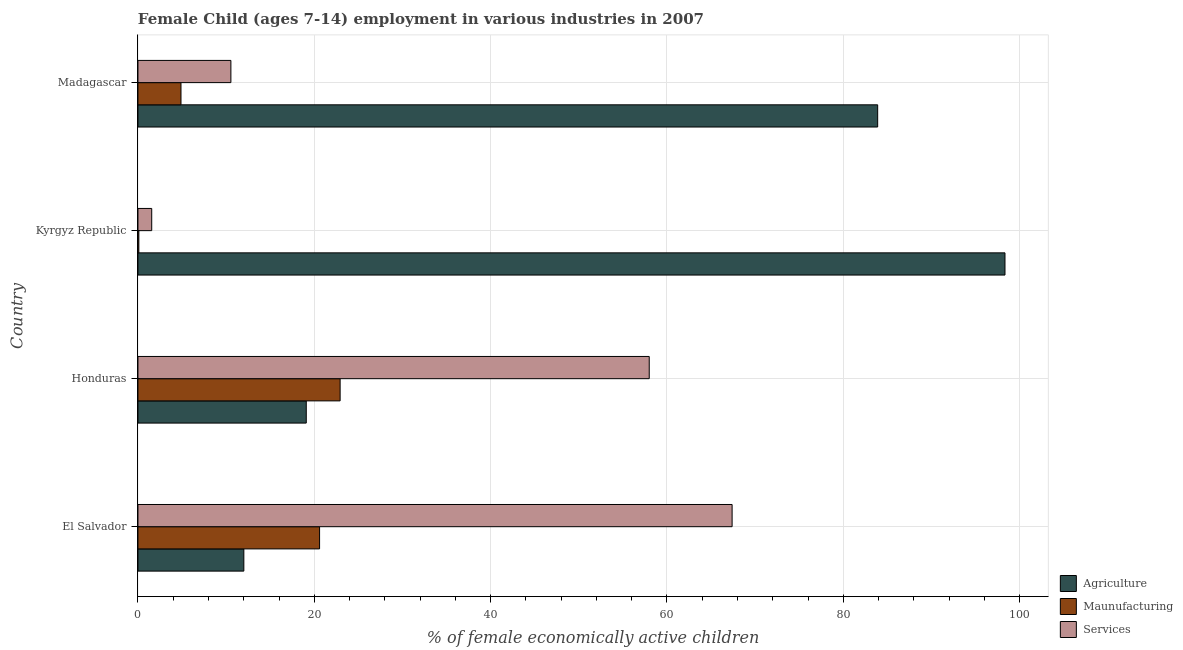How many different coloured bars are there?
Keep it short and to the point. 3. How many groups of bars are there?
Keep it short and to the point. 4. Are the number of bars per tick equal to the number of legend labels?
Give a very brief answer. Yes. Are the number of bars on each tick of the Y-axis equal?
Your answer should be very brief. Yes. How many bars are there on the 1st tick from the top?
Your answer should be compact. 3. How many bars are there on the 3rd tick from the bottom?
Your answer should be very brief. 3. What is the label of the 2nd group of bars from the top?
Keep it short and to the point. Kyrgyz Republic. What is the percentage of economically active children in services in Honduras?
Keep it short and to the point. 57.99. Across all countries, what is the maximum percentage of economically active children in services?
Provide a succinct answer. 67.39. Across all countries, what is the minimum percentage of economically active children in services?
Make the answer very short. 1.56. In which country was the percentage of economically active children in manufacturing maximum?
Ensure brevity in your answer.  Honduras. In which country was the percentage of economically active children in services minimum?
Your answer should be compact. Kyrgyz Republic. What is the total percentage of economically active children in agriculture in the graph?
Your answer should be very brief. 213.34. What is the difference between the percentage of economically active children in services in Honduras and that in Madagascar?
Offer a very short reply. 47.45. What is the difference between the percentage of economically active children in services in Madagascar and the percentage of economically active children in manufacturing in El Salvador?
Your answer should be very brief. -10.06. What is the average percentage of economically active children in manufacturing per country?
Provide a succinct answer. 12.13. What is the difference between the percentage of economically active children in services and percentage of economically active children in manufacturing in El Salvador?
Your answer should be very brief. 46.79. In how many countries, is the percentage of economically active children in manufacturing greater than 68 %?
Provide a succinct answer. 0. What is the difference between the highest and the second highest percentage of economically active children in agriculture?
Your answer should be very brief. 14.44. What is the difference between the highest and the lowest percentage of economically active children in services?
Ensure brevity in your answer.  65.83. In how many countries, is the percentage of economically active children in agriculture greater than the average percentage of economically active children in agriculture taken over all countries?
Offer a very short reply. 2. Is the sum of the percentage of economically active children in agriculture in Honduras and Kyrgyz Republic greater than the maximum percentage of economically active children in services across all countries?
Your answer should be very brief. Yes. What does the 1st bar from the top in Kyrgyz Republic represents?
Make the answer very short. Services. What does the 1st bar from the bottom in El Salvador represents?
Provide a short and direct response. Agriculture. Are all the bars in the graph horizontal?
Keep it short and to the point. Yes. What is the difference between two consecutive major ticks on the X-axis?
Ensure brevity in your answer.  20. Are the values on the major ticks of X-axis written in scientific E-notation?
Ensure brevity in your answer.  No. Does the graph contain any zero values?
Your answer should be compact. No. Where does the legend appear in the graph?
Your response must be concise. Bottom right. How are the legend labels stacked?
Offer a very short reply. Vertical. What is the title of the graph?
Offer a terse response. Female Child (ages 7-14) employment in various industries in 2007. What is the label or title of the X-axis?
Offer a very short reply. % of female economically active children. What is the label or title of the Y-axis?
Your response must be concise. Country. What is the % of female economically active children of Agriculture in El Salvador?
Your answer should be compact. 12.01. What is the % of female economically active children in Maunufacturing in El Salvador?
Make the answer very short. 20.6. What is the % of female economically active children of Services in El Salvador?
Offer a very short reply. 67.39. What is the % of female economically active children of Agriculture in Honduras?
Provide a succinct answer. 19.09. What is the % of female economically active children in Maunufacturing in Honduras?
Your answer should be very brief. 22.93. What is the % of female economically active children of Services in Honduras?
Keep it short and to the point. 57.99. What is the % of female economically active children of Agriculture in Kyrgyz Republic?
Make the answer very short. 98.34. What is the % of female economically active children of Services in Kyrgyz Republic?
Offer a terse response. 1.56. What is the % of female economically active children of Agriculture in Madagascar?
Your answer should be compact. 83.9. What is the % of female economically active children in Maunufacturing in Madagascar?
Give a very brief answer. 4.88. What is the % of female economically active children of Services in Madagascar?
Keep it short and to the point. 10.54. Across all countries, what is the maximum % of female economically active children in Agriculture?
Give a very brief answer. 98.34. Across all countries, what is the maximum % of female economically active children in Maunufacturing?
Offer a terse response. 22.93. Across all countries, what is the maximum % of female economically active children of Services?
Your response must be concise. 67.39. Across all countries, what is the minimum % of female economically active children of Agriculture?
Provide a short and direct response. 12.01. Across all countries, what is the minimum % of female economically active children of Services?
Provide a succinct answer. 1.56. What is the total % of female economically active children of Agriculture in the graph?
Ensure brevity in your answer.  213.34. What is the total % of female economically active children of Maunufacturing in the graph?
Keep it short and to the point. 48.51. What is the total % of female economically active children in Services in the graph?
Your answer should be compact. 137.48. What is the difference between the % of female economically active children of Agriculture in El Salvador and that in Honduras?
Offer a terse response. -7.08. What is the difference between the % of female economically active children of Maunufacturing in El Salvador and that in Honduras?
Keep it short and to the point. -2.33. What is the difference between the % of female economically active children of Agriculture in El Salvador and that in Kyrgyz Republic?
Offer a terse response. -86.33. What is the difference between the % of female economically active children in Services in El Salvador and that in Kyrgyz Republic?
Provide a short and direct response. 65.83. What is the difference between the % of female economically active children in Agriculture in El Salvador and that in Madagascar?
Offer a very short reply. -71.89. What is the difference between the % of female economically active children of Maunufacturing in El Salvador and that in Madagascar?
Provide a succinct answer. 15.72. What is the difference between the % of female economically active children in Services in El Salvador and that in Madagascar?
Give a very brief answer. 56.85. What is the difference between the % of female economically active children of Agriculture in Honduras and that in Kyrgyz Republic?
Your answer should be very brief. -79.25. What is the difference between the % of female economically active children of Maunufacturing in Honduras and that in Kyrgyz Republic?
Provide a short and direct response. 22.83. What is the difference between the % of female economically active children in Services in Honduras and that in Kyrgyz Republic?
Provide a succinct answer. 56.43. What is the difference between the % of female economically active children in Agriculture in Honduras and that in Madagascar?
Give a very brief answer. -64.81. What is the difference between the % of female economically active children in Maunufacturing in Honduras and that in Madagascar?
Provide a short and direct response. 18.05. What is the difference between the % of female economically active children in Services in Honduras and that in Madagascar?
Offer a very short reply. 47.45. What is the difference between the % of female economically active children in Agriculture in Kyrgyz Republic and that in Madagascar?
Make the answer very short. 14.44. What is the difference between the % of female economically active children in Maunufacturing in Kyrgyz Republic and that in Madagascar?
Offer a very short reply. -4.78. What is the difference between the % of female economically active children of Services in Kyrgyz Republic and that in Madagascar?
Your answer should be very brief. -8.98. What is the difference between the % of female economically active children in Agriculture in El Salvador and the % of female economically active children in Maunufacturing in Honduras?
Keep it short and to the point. -10.92. What is the difference between the % of female economically active children of Agriculture in El Salvador and the % of female economically active children of Services in Honduras?
Offer a terse response. -45.98. What is the difference between the % of female economically active children in Maunufacturing in El Salvador and the % of female economically active children in Services in Honduras?
Provide a short and direct response. -37.39. What is the difference between the % of female economically active children in Agriculture in El Salvador and the % of female economically active children in Maunufacturing in Kyrgyz Republic?
Your answer should be very brief. 11.91. What is the difference between the % of female economically active children of Agriculture in El Salvador and the % of female economically active children of Services in Kyrgyz Republic?
Offer a terse response. 10.45. What is the difference between the % of female economically active children of Maunufacturing in El Salvador and the % of female economically active children of Services in Kyrgyz Republic?
Ensure brevity in your answer.  19.04. What is the difference between the % of female economically active children in Agriculture in El Salvador and the % of female economically active children in Maunufacturing in Madagascar?
Offer a terse response. 7.13. What is the difference between the % of female economically active children in Agriculture in El Salvador and the % of female economically active children in Services in Madagascar?
Offer a very short reply. 1.47. What is the difference between the % of female economically active children in Maunufacturing in El Salvador and the % of female economically active children in Services in Madagascar?
Make the answer very short. 10.06. What is the difference between the % of female economically active children of Agriculture in Honduras and the % of female economically active children of Maunufacturing in Kyrgyz Republic?
Your response must be concise. 18.99. What is the difference between the % of female economically active children of Agriculture in Honduras and the % of female economically active children of Services in Kyrgyz Republic?
Keep it short and to the point. 17.53. What is the difference between the % of female economically active children in Maunufacturing in Honduras and the % of female economically active children in Services in Kyrgyz Republic?
Provide a succinct answer. 21.37. What is the difference between the % of female economically active children in Agriculture in Honduras and the % of female economically active children in Maunufacturing in Madagascar?
Offer a terse response. 14.21. What is the difference between the % of female economically active children of Agriculture in Honduras and the % of female economically active children of Services in Madagascar?
Offer a terse response. 8.55. What is the difference between the % of female economically active children of Maunufacturing in Honduras and the % of female economically active children of Services in Madagascar?
Make the answer very short. 12.39. What is the difference between the % of female economically active children in Agriculture in Kyrgyz Republic and the % of female economically active children in Maunufacturing in Madagascar?
Ensure brevity in your answer.  93.46. What is the difference between the % of female economically active children in Agriculture in Kyrgyz Republic and the % of female economically active children in Services in Madagascar?
Provide a succinct answer. 87.8. What is the difference between the % of female economically active children of Maunufacturing in Kyrgyz Republic and the % of female economically active children of Services in Madagascar?
Keep it short and to the point. -10.44. What is the average % of female economically active children of Agriculture per country?
Offer a terse response. 53.34. What is the average % of female economically active children of Maunufacturing per country?
Offer a very short reply. 12.13. What is the average % of female economically active children of Services per country?
Your answer should be compact. 34.37. What is the difference between the % of female economically active children of Agriculture and % of female economically active children of Maunufacturing in El Salvador?
Offer a terse response. -8.59. What is the difference between the % of female economically active children of Agriculture and % of female economically active children of Services in El Salvador?
Offer a terse response. -55.38. What is the difference between the % of female economically active children of Maunufacturing and % of female economically active children of Services in El Salvador?
Offer a very short reply. -46.79. What is the difference between the % of female economically active children in Agriculture and % of female economically active children in Maunufacturing in Honduras?
Your answer should be compact. -3.84. What is the difference between the % of female economically active children in Agriculture and % of female economically active children in Services in Honduras?
Offer a terse response. -38.9. What is the difference between the % of female economically active children in Maunufacturing and % of female economically active children in Services in Honduras?
Offer a very short reply. -35.06. What is the difference between the % of female economically active children in Agriculture and % of female economically active children in Maunufacturing in Kyrgyz Republic?
Ensure brevity in your answer.  98.24. What is the difference between the % of female economically active children of Agriculture and % of female economically active children of Services in Kyrgyz Republic?
Your answer should be very brief. 96.78. What is the difference between the % of female economically active children of Maunufacturing and % of female economically active children of Services in Kyrgyz Republic?
Your response must be concise. -1.46. What is the difference between the % of female economically active children of Agriculture and % of female economically active children of Maunufacturing in Madagascar?
Ensure brevity in your answer.  79.02. What is the difference between the % of female economically active children in Agriculture and % of female economically active children in Services in Madagascar?
Offer a terse response. 73.36. What is the difference between the % of female economically active children in Maunufacturing and % of female economically active children in Services in Madagascar?
Your answer should be compact. -5.66. What is the ratio of the % of female economically active children of Agriculture in El Salvador to that in Honduras?
Offer a terse response. 0.63. What is the ratio of the % of female economically active children of Maunufacturing in El Salvador to that in Honduras?
Give a very brief answer. 0.9. What is the ratio of the % of female economically active children of Services in El Salvador to that in Honduras?
Provide a succinct answer. 1.16. What is the ratio of the % of female economically active children in Agriculture in El Salvador to that in Kyrgyz Republic?
Give a very brief answer. 0.12. What is the ratio of the % of female economically active children in Maunufacturing in El Salvador to that in Kyrgyz Republic?
Your answer should be compact. 206. What is the ratio of the % of female economically active children of Services in El Salvador to that in Kyrgyz Republic?
Make the answer very short. 43.2. What is the ratio of the % of female economically active children of Agriculture in El Salvador to that in Madagascar?
Provide a succinct answer. 0.14. What is the ratio of the % of female economically active children in Maunufacturing in El Salvador to that in Madagascar?
Ensure brevity in your answer.  4.22. What is the ratio of the % of female economically active children in Services in El Salvador to that in Madagascar?
Offer a terse response. 6.39. What is the ratio of the % of female economically active children in Agriculture in Honduras to that in Kyrgyz Republic?
Provide a succinct answer. 0.19. What is the ratio of the % of female economically active children in Maunufacturing in Honduras to that in Kyrgyz Republic?
Ensure brevity in your answer.  229.3. What is the ratio of the % of female economically active children of Services in Honduras to that in Kyrgyz Republic?
Your response must be concise. 37.17. What is the ratio of the % of female economically active children of Agriculture in Honduras to that in Madagascar?
Provide a succinct answer. 0.23. What is the ratio of the % of female economically active children of Maunufacturing in Honduras to that in Madagascar?
Keep it short and to the point. 4.7. What is the ratio of the % of female economically active children of Services in Honduras to that in Madagascar?
Provide a short and direct response. 5.5. What is the ratio of the % of female economically active children of Agriculture in Kyrgyz Republic to that in Madagascar?
Your answer should be very brief. 1.17. What is the ratio of the % of female economically active children in Maunufacturing in Kyrgyz Republic to that in Madagascar?
Provide a succinct answer. 0.02. What is the ratio of the % of female economically active children in Services in Kyrgyz Republic to that in Madagascar?
Make the answer very short. 0.15. What is the difference between the highest and the second highest % of female economically active children in Agriculture?
Offer a terse response. 14.44. What is the difference between the highest and the second highest % of female economically active children in Maunufacturing?
Keep it short and to the point. 2.33. What is the difference between the highest and the second highest % of female economically active children of Services?
Provide a short and direct response. 9.4. What is the difference between the highest and the lowest % of female economically active children of Agriculture?
Your answer should be very brief. 86.33. What is the difference between the highest and the lowest % of female economically active children in Maunufacturing?
Your answer should be compact. 22.83. What is the difference between the highest and the lowest % of female economically active children of Services?
Your answer should be very brief. 65.83. 